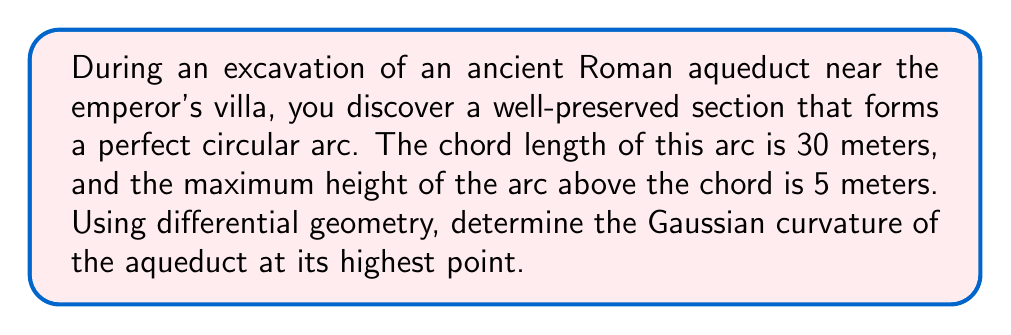Give your solution to this math problem. To solve this problem, we'll follow these steps:

1) First, we need to find the radius of the circular arc. We can do this using the equation for a circular segment:

   $$ h = R - \sqrt{R^2 - (\frac{c}{2})^2} $$

   where $h$ is the height of the arc, $R$ is the radius, and $c$ is the chord length.

2) Substituting our known values:

   $$ 5 = R - \sqrt{R^2 - 15^2} $$

3) Solving this equation (which can be done algebraically or numerically), we get:

   $$ R \approx 23.125 \text{ meters} $$

4) Now, we need to understand that for a surface of revolution (which our aqueduct section approximates), the Gaussian curvature $K$ at a point is given by:

   $$ K = \frac{f''(r)}{f(r)(1 + (f'(r))^2)} $$

   where $f(r)$ is the function that generates the surface when rotated around the axis.

5) For a circle centered at $(0,R)$, this function is:

   $$ f(r) = \sqrt{R^2 - r^2} $$

6) We need to calculate $f'(r)$ and $f''(r)$:

   $$ f'(r) = -\frac{r}{\sqrt{R^2 - r^2}} $$
   
   $$ f''(r) = -\frac{R^2}{(R^2 - r^2)^{3/2}} $$

7) At the highest point of the arc, $r = 0$, so:

   $$ f(0) = R $$
   $$ f'(0) = 0 $$
   $$ f''(0) = -\frac{1}{R} $$

8) Substituting these into our curvature formula:

   $$ K = \frac{-\frac{1}{R}}{R(1 + 0^2)} = -\frac{1}{R^2} $$

9) Finally, we can calculate the Gaussian curvature:

   $$ K = -\frac{1}{(23.125)^2} \approx -0.001870 \text{ m}^{-2} $$
Answer: The Gaussian curvature of the aqueduct at its highest point is approximately $-0.001870 \text{ m}^{-2}$. 